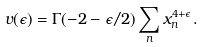Convert formula to latex. <formula><loc_0><loc_0><loc_500><loc_500>v ( \epsilon ) = \Gamma ( - 2 - \epsilon / 2 ) \sum _ { n } x _ { n } ^ { 4 + \epsilon } .</formula> 